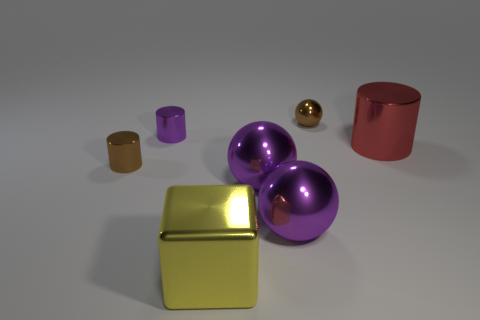What color is the tiny sphere that is the same material as the big block?
Your response must be concise. Brown. What material is the brown thing to the left of the small sphere?
Your answer should be very brief. Metal. Do the red object and the brown shiny object in front of the red metal thing have the same shape?
Your response must be concise. Yes. The tiny object that is both behind the brown cylinder and in front of the tiny ball is made of what material?
Your answer should be compact. Metal. What is the color of the other cylinder that is the same size as the brown cylinder?
Your answer should be compact. Purple. Do the red cylinder and the small brown object that is to the left of the metallic block have the same material?
Keep it short and to the point. Yes. What number of other objects are the same size as the brown sphere?
Give a very brief answer. 2. There is a tiny shiny cylinder that is behind the shiny cylinder that is to the right of the block; is there a metallic object to the right of it?
Offer a very short reply. Yes. The red object is what size?
Your answer should be very brief. Large. What is the size of the brown thing that is left of the tiny ball?
Give a very brief answer. Small. 